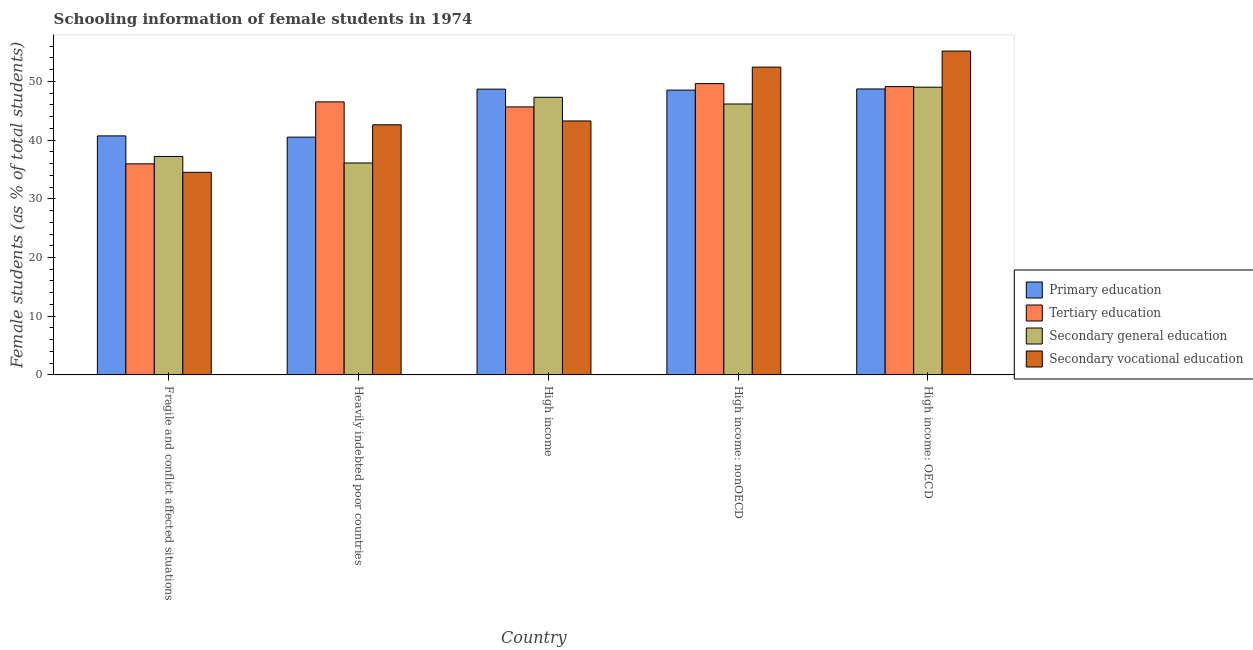How many groups of bars are there?
Give a very brief answer. 5. Are the number of bars per tick equal to the number of legend labels?
Offer a terse response. Yes. Are the number of bars on each tick of the X-axis equal?
Your answer should be compact. Yes. How many bars are there on the 4th tick from the left?
Keep it short and to the point. 4. How many bars are there on the 5th tick from the right?
Offer a terse response. 4. What is the label of the 4th group of bars from the left?
Your answer should be compact. High income: nonOECD. In how many cases, is the number of bars for a given country not equal to the number of legend labels?
Your response must be concise. 0. What is the percentage of female students in tertiary education in High income: nonOECD?
Your answer should be compact. 49.62. Across all countries, what is the maximum percentage of female students in primary education?
Keep it short and to the point. 48.71. Across all countries, what is the minimum percentage of female students in tertiary education?
Offer a very short reply. 35.95. In which country was the percentage of female students in tertiary education maximum?
Provide a short and direct response. High income: nonOECD. In which country was the percentage of female students in tertiary education minimum?
Provide a succinct answer. Fragile and conflict affected situations. What is the total percentage of female students in primary education in the graph?
Offer a very short reply. 227.09. What is the difference between the percentage of female students in tertiary education in Fragile and conflict affected situations and that in High income: nonOECD?
Offer a very short reply. -13.67. What is the difference between the percentage of female students in secondary vocational education in Heavily indebted poor countries and the percentage of female students in secondary education in High income: nonOECD?
Your answer should be compact. -3.54. What is the average percentage of female students in tertiary education per country?
Give a very brief answer. 45.37. What is the difference between the percentage of female students in secondary education and percentage of female students in primary education in Heavily indebted poor countries?
Provide a short and direct response. -4.4. What is the ratio of the percentage of female students in primary education in Heavily indebted poor countries to that in High income: OECD?
Give a very brief answer. 0.83. What is the difference between the highest and the second highest percentage of female students in secondary vocational education?
Make the answer very short. 2.73. What is the difference between the highest and the lowest percentage of female students in secondary education?
Give a very brief answer. 12.91. In how many countries, is the percentage of female students in primary education greater than the average percentage of female students in primary education taken over all countries?
Your response must be concise. 3. Is the sum of the percentage of female students in tertiary education in Heavily indebted poor countries and High income: nonOECD greater than the maximum percentage of female students in secondary education across all countries?
Ensure brevity in your answer.  Yes. Is it the case that in every country, the sum of the percentage of female students in primary education and percentage of female students in secondary education is greater than the sum of percentage of female students in tertiary education and percentage of female students in secondary vocational education?
Keep it short and to the point. No. What does the 3rd bar from the left in High income: nonOECD represents?
Ensure brevity in your answer.  Secondary general education. How many bars are there?
Ensure brevity in your answer.  20. Are all the bars in the graph horizontal?
Your answer should be compact. No. How many countries are there in the graph?
Make the answer very short. 5. Does the graph contain grids?
Your response must be concise. No. How many legend labels are there?
Give a very brief answer. 4. What is the title of the graph?
Your answer should be compact. Schooling information of female students in 1974. What is the label or title of the Y-axis?
Provide a short and direct response. Female students (as % of total students). What is the Female students (as % of total students) in Primary education in Fragile and conflict affected situations?
Offer a very short reply. 40.71. What is the Female students (as % of total students) of Tertiary education in Fragile and conflict affected situations?
Keep it short and to the point. 35.95. What is the Female students (as % of total students) of Secondary general education in Fragile and conflict affected situations?
Give a very brief answer. 37.21. What is the Female students (as % of total students) of Secondary vocational education in Fragile and conflict affected situations?
Offer a terse response. 34.51. What is the Female students (as % of total students) of Primary education in Heavily indebted poor countries?
Offer a terse response. 40.5. What is the Female students (as % of total students) of Tertiary education in Heavily indebted poor countries?
Provide a short and direct response. 46.5. What is the Female students (as % of total students) of Secondary general education in Heavily indebted poor countries?
Offer a terse response. 36.1. What is the Female students (as % of total students) of Secondary vocational education in Heavily indebted poor countries?
Give a very brief answer. 42.6. What is the Female students (as % of total students) in Primary education in High income?
Provide a succinct answer. 48.67. What is the Female students (as % of total students) of Tertiary education in High income?
Provide a succinct answer. 45.65. What is the Female students (as % of total students) in Secondary general education in High income?
Offer a terse response. 47.29. What is the Female students (as % of total students) in Secondary vocational education in High income?
Make the answer very short. 43.25. What is the Female students (as % of total students) in Primary education in High income: nonOECD?
Make the answer very short. 48.51. What is the Female students (as % of total students) of Tertiary education in High income: nonOECD?
Your response must be concise. 49.62. What is the Female students (as % of total students) of Secondary general education in High income: nonOECD?
Make the answer very short. 46.14. What is the Female students (as % of total students) in Secondary vocational education in High income: nonOECD?
Offer a terse response. 52.42. What is the Female students (as % of total students) in Primary education in High income: OECD?
Ensure brevity in your answer.  48.71. What is the Female students (as % of total students) of Tertiary education in High income: OECD?
Your response must be concise. 49.11. What is the Female students (as % of total students) of Secondary general education in High income: OECD?
Your answer should be compact. 49.01. What is the Female students (as % of total students) of Secondary vocational education in High income: OECD?
Give a very brief answer. 55.16. Across all countries, what is the maximum Female students (as % of total students) in Primary education?
Your answer should be very brief. 48.71. Across all countries, what is the maximum Female students (as % of total students) in Tertiary education?
Your answer should be compact. 49.62. Across all countries, what is the maximum Female students (as % of total students) of Secondary general education?
Offer a very short reply. 49.01. Across all countries, what is the maximum Female students (as % of total students) of Secondary vocational education?
Offer a very short reply. 55.16. Across all countries, what is the minimum Female students (as % of total students) of Primary education?
Offer a terse response. 40.5. Across all countries, what is the minimum Female students (as % of total students) of Tertiary education?
Ensure brevity in your answer.  35.95. Across all countries, what is the minimum Female students (as % of total students) in Secondary general education?
Offer a terse response. 36.1. Across all countries, what is the minimum Female students (as % of total students) of Secondary vocational education?
Your answer should be compact. 34.51. What is the total Female students (as % of total students) of Primary education in the graph?
Your answer should be compact. 227.09. What is the total Female students (as % of total students) of Tertiary education in the graph?
Your answer should be compact. 226.83. What is the total Female students (as % of total students) of Secondary general education in the graph?
Offer a very short reply. 215.75. What is the total Female students (as % of total students) of Secondary vocational education in the graph?
Make the answer very short. 227.95. What is the difference between the Female students (as % of total students) in Primary education in Fragile and conflict affected situations and that in Heavily indebted poor countries?
Make the answer very short. 0.21. What is the difference between the Female students (as % of total students) in Tertiary education in Fragile and conflict affected situations and that in Heavily indebted poor countries?
Give a very brief answer. -10.55. What is the difference between the Female students (as % of total students) in Secondary general education in Fragile and conflict affected situations and that in Heavily indebted poor countries?
Your response must be concise. 1.11. What is the difference between the Female students (as % of total students) of Secondary vocational education in Fragile and conflict affected situations and that in Heavily indebted poor countries?
Offer a terse response. -8.09. What is the difference between the Female students (as % of total students) in Primary education in Fragile and conflict affected situations and that in High income?
Provide a short and direct response. -7.96. What is the difference between the Female students (as % of total students) in Tertiary education in Fragile and conflict affected situations and that in High income?
Your answer should be very brief. -9.7. What is the difference between the Female students (as % of total students) in Secondary general education in Fragile and conflict affected situations and that in High income?
Offer a very short reply. -10.08. What is the difference between the Female students (as % of total students) in Secondary vocational education in Fragile and conflict affected situations and that in High income?
Provide a succinct answer. -8.75. What is the difference between the Female students (as % of total students) in Primary education in Fragile and conflict affected situations and that in High income: nonOECD?
Your answer should be very brief. -7.8. What is the difference between the Female students (as % of total students) of Tertiary education in Fragile and conflict affected situations and that in High income: nonOECD?
Your response must be concise. -13.67. What is the difference between the Female students (as % of total students) in Secondary general education in Fragile and conflict affected situations and that in High income: nonOECD?
Give a very brief answer. -8.94. What is the difference between the Female students (as % of total students) of Secondary vocational education in Fragile and conflict affected situations and that in High income: nonOECD?
Offer a terse response. -17.92. What is the difference between the Female students (as % of total students) in Primary education in Fragile and conflict affected situations and that in High income: OECD?
Make the answer very short. -8. What is the difference between the Female students (as % of total students) in Tertiary education in Fragile and conflict affected situations and that in High income: OECD?
Ensure brevity in your answer.  -13.16. What is the difference between the Female students (as % of total students) in Secondary general education in Fragile and conflict affected situations and that in High income: OECD?
Your response must be concise. -11.8. What is the difference between the Female students (as % of total students) in Secondary vocational education in Fragile and conflict affected situations and that in High income: OECD?
Provide a succinct answer. -20.65. What is the difference between the Female students (as % of total students) in Primary education in Heavily indebted poor countries and that in High income?
Your answer should be very brief. -8.17. What is the difference between the Female students (as % of total students) of Tertiary education in Heavily indebted poor countries and that in High income?
Give a very brief answer. 0.85. What is the difference between the Female students (as % of total students) of Secondary general education in Heavily indebted poor countries and that in High income?
Your answer should be very brief. -11.19. What is the difference between the Female students (as % of total students) in Secondary vocational education in Heavily indebted poor countries and that in High income?
Make the answer very short. -0.65. What is the difference between the Female students (as % of total students) of Primary education in Heavily indebted poor countries and that in High income: nonOECD?
Your response must be concise. -8.01. What is the difference between the Female students (as % of total students) of Tertiary education in Heavily indebted poor countries and that in High income: nonOECD?
Give a very brief answer. -3.12. What is the difference between the Female students (as % of total students) in Secondary general education in Heavily indebted poor countries and that in High income: nonOECD?
Make the answer very short. -10.05. What is the difference between the Female students (as % of total students) in Secondary vocational education in Heavily indebted poor countries and that in High income: nonOECD?
Your answer should be very brief. -9.82. What is the difference between the Female students (as % of total students) of Primary education in Heavily indebted poor countries and that in High income: OECD?
Your answer should be compact. -8.21. What is the difference between the Female students (as % of total students) in Tertiary education in Heavily indebted poor countries and that in High income: OECD?
Make the answer very short. -2.61. What is the difference between the Female students (as % of total students) in Secondary general education in Heavily indebted poor countries and that in High income: OECD?
Your answer should be compact. -12.91. What is the difference between the Female students (as % of total students) of Secondary vocational education in Heavily indebted poor countries and that in High income: OECD?
Give a very brief answer. -12.56. What is the difference between the Female students (as % of total students) in Primary education in High income and that in High income: nonOECD?
Ensure brevity in your answer.  0.17. What is the difference between the Female students (as % of total students) of Tertiary education in High income and that in High income: nonOECD?
Provide a succinct answer. -3.97. What is the difference between the Female students (as % of total students) of Secondary general education in High income and that in High income: nonOECD?
Your answer should be compact. 1.14. What is the difference between the Female students (as % of total students) of Secondary vocational education in High income and that in High income: nonOECD?
Provide a short and direct response. -9.17. What is the difference between the Female students (as % of total students) in Primary education in High income and that in High income: OECD?
Provide a short and direct response. -0.03. What is the difference between the Female students (as % of total students) in Tertiary education in High income and that in High income: OECD?
Give a very brief answer. -3.46. What is the difference between the Female students (as % of total students) of Secondary general education in High income and that in High income: OECD?
Ensure brevity in your answer.  -1.72. What is the difference between the Female students (as % of total students) of Secondary vocational education in High income and that in High income: OECD?
Provide a succinct answer. -11.91. What is the difference between the Female students (as % of total students) of Primary education in High income: nonOECD and that in High income: OECD?
Your answer should be very brief. -0.2. What is the difference between the Female students (as % of total students) of Tertiary education in High income: nonOECD and that in High income: OECD?
Make the answer very short. 0.51. What is the difference between the Female students (as % of total students) in Secondary general education in High income: nonOECD and that in High income: OECD?
Give a very brief answer. -2.86. What is the difference between the Female students (as % of total students) of Secondary vocational education in High income: nonOECD and that in High income: OECD?
Offer a terse response. -2.73. What is the difference between the Female students (as % of total students) in Primary education in Fragile and conflict affected situations and the Female students (as % of total students) in Tertiary education in Heavily indebted poor countries?
Your answer should be very brief. -5.79. What is the difference between the Female students (as % of total students) of Primary education in Fragile and conflict affected situations and the Female students (as % of total students) of Secondary general education in Heavily indebted poor countries?
Your response must be concise. 4.61. What is the difference between the Female students (as % of total students) in Primary education in Fragile and conflict affected situations and the Female students (as % of total students) in Secondary vocational education in Heavily indebted poor countries?
Your response must be concise. -1.89. What is the difference between the Female students (as % of total students) of Tertiary education in Fragile and conflict affected situations and the Female students (as % of total students) of Secondary general education in Heavily indebted poor countries?
Your response must be concise. -0.15. What is the difference between the Female students (as % of total students) of Tertiary education in Fragile and conflict affected situations and the Female students (as % of total students) of Secondary vocational education in Heavily indebted poor countries?
Ensure brevity in your answer.  -6.65. What is the difference between the Female students (as % of total students) in Secondary general education in Fragile and conflict affected situations and the Female students (as % of total students) in Secondary vocational education in Heavily indebted poor countries?
Give a very brief answer. -5.39. What is the difference between the Female students (as % of total students) in Primary education in Fragile and conflict affected situations and the Female students (as % of total students) in Tertiary education in High income?
Keep it short and to the point. -4.94. What is the difference between the Female students (as % of total students) of Primary education in Fragile and conflict affected situations and the Female students (as % of total students) of Secondary general education in High income?
Your answer should be compact. -6.58. What is the difference between the Female students (as % of total students) in Primary education in Fragile and conflict affected situations and the Female students (as % of total students) in Secondary vocational education in High income?
Your response must be concise. -2.54. What is the difference between the Female students (as % of total students) in Tertiary education in Fragile and conflict affected situations and the Female students (as % of total students) in Secondary general education in High income?
Provide a succinct answer. -11.34. What is the difference between the Female students (as % of total students) of Tertiary education in Fragile and conflict affected situations and the Female students (as % of total students) of Secondary vocational education in High income?
Ensure brevity in your answer.  -7.3. What is the difference between the Female students (as % of total students) of Secondary general education in Fragile and conflict affected situations and the Female students (as % of total students) of Secondary vocational education in High income?
Ensure brevity in your answer.  -6.05. What is the difference between the Female students (as % of total students) in Primary education in Fragile and conflict affected situations and the Female students (as % of total students) in Tertiary education in High income: nonOECD?
Provide a succinct answer. -8.91. What is the difference between the Female students (as % of total students) in Primary education in Fragile and conflict affected situations and the Female students (as % of total students) in Secondary general education in High income: nonOECD?
Provide a succinct answer. -5.44. What is the difference between the Female students (as % of total students) of Primary education in Fragile and conflict affected situations and the Female students (as % of total students) of Secondary vocational education in High income: nonOECD?
Ensure brevity in your answer.  -11.72. What is the difference between the Female students (as % of total students) in Tertiary education in Fragile and conflict affected situations and the Female students (as % of total students) in Secondary general education in High income: nonOECD?
Keep it short and to the point. -10.19. What is the difference between the Female students (as % of total students) of Tertiary education in Fragile and conflict affected situations and the Female students (as % of total students) of Secondary vocational education in High income: nonOECD?
Your response must be concise. -16.47. What is the difference between the Female students (as % of total students) of Secondary general education in Fragile and conflict affected situations and the Female students (as % of total students) of Secondary vocational education in High income: nonOECD?
Your answer should be very brief. -15.22. What is the difference between the Female students (as % of total students) in Primary education in Fragile and conflict affected situations and the Female students (as % of total students) in Tertiary education in High income: OECD?
Provide a short and direct response. -8.4. What is the difference between the Female students (as % of total students) in Primary education in Fragile and conflict affected situations and the Female students (as % of total students) in Secondary general education in High income: OECD?
Your answer should be very brief. -8.3. What is the difference between the Female students (as % of total students) in Primary education in Fragile and conflict affected situations and the Female students (as % of total students) in Secondary vocational education in High income: OECD?
Provide a succinct answer. -14.45. What is the difference between the Female students (as % of total students) in Tertiary education in Fragile and conflict affected situations and the Female students (as % of total students) in Secondary general education in High income: OECD?
Your answer should be very brief. -13.06. What is the difference between the Female students (as % of total students) of Tertiary education in Fragile and conflict affected situations and the Female students (as % of total students) of Secondary vocational education in High income: OECD?
Ensure brevity in your answer.  -19.21. What is the difference between the Female students (as % of total students) in Secondary general education in Fragile and conflict affected situations and the Female students (as % of total students) in Secondary vocational education in High income: OECD?
Provide a succinct answer. -17.95. What is the difference between the Female students (as % of total students) of Primary education in Heavily indebted poor countries and the Female students (as % of total students) of Tertiary education in High income?
Provide a succinct answer. -5.15. What is the difference between the Female students (as % of total students) of Primary education in Heavily indebted poor countries and the Female students (as % of total students) of Secondary general education in High income?
Offer a very short reply. -6.79. What is the difference between the Female students (as % of total students) of Primary education in Heavily indebted poor countries and the Female students (as % of total students) of Secondary vocational education in High income?
Give a very brief answer. -2.75. What is the difference between the Female students (as % of total students) of Tertiary education in Heavily indebted poor countries and the Female students (as % of total students) of Secondary general education in High income?
Provide a short and direct response. -0.79. What is the difference between the Female students (as % of total students) of Tertiary education in Heavily indebted poor countries and the Female students (as % of total students) of Secondary vocational education in High income?
Your response must be concise. 3.25. What is the difference between the Female students (as % of total students) of Secondary general education in Heavily indebted poor countries and the Female students (as % of total students) of Secondary vocational education in High income?
Provide a succinct answer. -7.16. What is the difference between the Female students (as % of total students) in Primary education in Heavily indebted poor countries and the Female students (as % of total students) in Tertiary education in High income: nonOECD?
Give a very brief answer. -9.12. What is the difference between the Female students (as % of total students) of Primary education in Heavily indebted poor countries and the Female students (as % of total students) of Secondary general education in High income: nonOECD?
Your response must be concise. -5.65. What is the difference between the Female students (as % of total students) in Primary education in Heavily indebted poor countries and the Female students (as % of total students) in Secondary vocational education in High income: nonOECD?
Offer a very short reply. -11.93. What is the difference between the Female students (as % of total students) in Tertiary education in Heavily indebted poor countries and the Female students (as % of total students) in Secondary general education in High income: nonOECD?
Give a very brief answer. 0.36. What is the difference between the Female students (as % of total students) of Tertiary education in Heavily indebted poor countries and the Female students (as % of total students) of Secondary vocational education in High income: nonOECD?
Provide a short and direct response. -5.92. What is the difference between the Female students (as % of total students) in Secondary general education in Heavily indebted poor countries and the Female students (as % of total students) in Secondary vocational education in High income: nonOECD?
Provide a short and direct response. -16.33. What is the difference between the Female students (as % of total students) in Primary education in Heavily indebted poor countries and the Female students (as % of total students) in Tertiary education in High income: OECD?
Your answer should be very brief. -8.61. What is the difference between the Female students (as % of total students) in Primary education in Heavily indebted poor countries and the Female students (as % of total students) in Secondary general education in High income: OECD?
Provide a succinct answer. -8.51. What is the difference between the Female students (as % of total students) of Primary education in Heavily indebted poor countries and the Female students (as % of total students) of Secondary vocational education in High income: OECD?
Keep it short and to the point. -14.66. What is the difference between the Female students (as % of total students) of Tertiary education in Heavily indebted poor countries and the Female students (as % of total students) of Secondary general education in High income: OECD?
Provide a succinct answer. -2.51. What is the difference between the Female students (as % of total students) of Tertiary education in Heavily indebted poor countries and the Female students (as % of total students) of Secondary vocational education in High income: OECD?
Your answer should be compact. -8.66. What is the difference between the Female students (as % of total students) in Secondary general education in Heavily indebted poor countries and the Female students (as % of total students) in Secondary vocational education in High income: OECD?
Make the answer very short. -19.06. What is the difference between the Female students (as % of total students) of Primary education in High income and the Female students (as % of total students) of Tertiary education in High income: nonOECD?
Make the answer very short. -0.94. What is the difference between the Female students (as % of total students) of Primary education in High income and the Female students (as % of total students) of Secondary general education in High income: nonOECD?
Your response must be concise. 2.53. What is the difference between the Female students (as % of total students) of Primary education in High income and the Female students (as % of total students) of Secondary vocational education in High income: nonOECD?
Make the answer very short. -3.75. What is the difference between the Female students (as % of total students) in Tertiary education in High income and the Female students (as % of total students) in Secondary general education in High income: nonOECD?
Your answer should be compact. -0.5. What is the difference between the Female students (as % of total students) of Tertiary education in High income and the Female students (as % of total students) of Secondary vocational education in High income: nonOECD?
Your answer should be very brief. -6.78. What is the difference between the Female students (as % of total students) of Secondary general education in High income and the Female students (as % of total students) of Secondary vocational education in High income: nonOECD?
Keep it short and to the point. -5.14. What is the difference between the Female students (as % of total students) in Primary education in High income and the Female students (as % of total students) in Tertiary education in High income: OECD?
Offer a very short reply. -0.44. What is the difference between the Female students (as % of total students) of Primary education in High income and the Female students (as % of total students) of Secondary general education in High income: OECD?
Your answer should be compact. -0.33. What is the difference between the Female students (as % of total students) of Primary education in High income and the Female students (as % of total students) of Secondary vocational education in High income: OECD?
Keep it short and to the point. -6.49. What is the difference between the Female students (as % of total students) in Tertiary education in High income and the Female students (as % of total students) in Secondary general education in High income: OECD?
Your response must be concise. -3.36. What is the difference between the Female students (as % of total students) in Tertiary education in High income and the Female students (as % of total students) in Secondary vocational education in High income: OECD?
Offer a terse response. -9.51. What is the difference between the Female students (as % of total students) of Secondary general education in High income and the Female students (as % of total students) of Secondary vocational education in High income: OECD?
Provide a succinct answer. -7.87. What is the difference between the Female students (as % of total students) in Primary education in High income: nonOECD and the Female students (as % of total students) in Tertiary education in High income: OECD?
Provide a succinct answer. -0.6. What is the difference between the Female students (as % of total students) of Primary education in High income: nonOECD and the Female students (as % of total students) of Secondary general education in High income: OECD?
Your answer should be compact. -0.5. What is the difference between the Female students (as % of total students) in Primary education in High income: nonOECD and the Female students (as % of total students) in Secondary vocational education in High income: OECD?
Provide a short and direct response. -6.65. What is the difference between the Female students (as % of total students) in Tertiary education in High income: nonOECD and the Female students (as % of total students) in Secondary general education in High income: OECD?
Your answer should be compact. 0.61. What is the difference between the Female students (as % of total students) of Tertiary education in High income: nonOECD and the Female students (as % of total students) of Secondary vocational education in High income: OECD?
Offer a very short reply. -5.54. What is the difference between the Female students (as % of total students) in Secondary general education in High income: nonOECD and the Female students (as % of total students) in Secondary vocational education in High income: OECD?
Your answer should be compact. -9.01. What is the average Female students (as % of total students) in Primary education per country?
Provide a short and direct response. 45.42. What is the average Female students (as % of total students) of Tertiary education per country?
Provide a succinct answer. 45.37. What is the average Female students (as % of total students) of Secondary general education per country?
Provide a short and direct response. 43.15. What is the average Female students (as % of total students) of Secondary vocational education per country?
Give a very brief answer. 45.59. What is the difference between the Female students (as % of total students) of Primary education and Female students (as % of total students) of Tertiary education in Fragile and conflict affected situations?
Your answer should be compact. 4.76. What is the difference between the Female students (as % of total students) of Primary education and Female students (as % of total students) of Secondary general education in Fragile and conflict affected situations?
Make the answer very short. 3.5. What is the difference between the Female students (as % of total students) of Primary education and Female students (as % of total students) of Secondary vocational education in Fragile and conflict affected situations?
Make the answer very short. 6.2. What is the difference between the Female students (as % of total students) of Tertiary education and Female students (as % of total students) of Secondary general education in Fragile and conflict affected situations?
Make the answer very short. -1.26. What is the difference between the Female students (as % of total students) of Tertiary education and Female students (as % of total students) of Secondary vocational education in Fragile and conflict affected situations?
Your answer should be very brief. 1.44. What is the difference between the Female students (as % of total students) of Secondary general education and Female students (as % of total students) of Secondary vocational education in Fragile and conflict affected situations?
Your response must be concise. 2.7. What is the difference between the Female students (as % of total students) in Primary education and Female students (as % of total students) in Tertiary education in Heavily indebted poor countries?
Give a very brief answer. -6. What is the difference between the Female students (as % of total students) of Primary education and Female students (as % of total students) of Secondary general education in Heavily indebted poor countries?
Make the answer very short. 4.4. What is the difference between the Female students (as % of total students) in Primary education and Female students (as % of total students) in Secondary vocational education in Heavily indebted poor countries?
Ensure brevity in your answer.  -2.1. What is the difference between the Female students (as % of total students) of Tertiary education and Female students (as % of total students) of Secondary general education in Heavily indebted poor countries?
Offer a very short reply. 10.4. What is the difference between the Female students (as % of total students) of Tertiary education and Female students (as % of total students) of Secondary vocational education in Heavily indebted poor countries?
Give a very brief answer. 3.9. What is the difference between the Female students (as % of total students) of Secondary general education and Female students (as % of total students) of Secondary vocational education in Heavily indebted poor countries?
Provide a short and direct response. -6.5. What is the difference between the Female students (as % of total students) in Primary education and Female students (as % of total students) in Tertiary education in High income?
Ensure brevity in your answer.  3.02. What is the difference between the Female students (as % of total students) in Primary education and Female students (as % of total students) in Secondary general education in High income?
Offer a very short reply. 1.39. What is the difference between the Female students (as % of total students) in Primary education and Female students (as % of total students) in Secondary vocational education in High income?
Give a very brief answer. 5.42. What is the difference between the Female students (as % of total students) in Tertiary education and Female students (as % of total students) in Secondary general education in High income?
Provide a short and direct response. -1.64. What is the difference between the Female students (as % of total students) of Tertiary education and Female students (as % of total students) of Secondary vocational education in High income?
Ensure brevity in your answer.  2.4. What is the difference between the Female students (as % of total students) of Secondary general education and Female students (as % of total students) of Secondary vocational education in High income?
Give a very brief answer. 4.03. What is the difference between the Female students (as % of total students) of Primary education and Female students (as % of total students) of Tertiary education in High income: nonOECD?
Ensure brevity in your answer.  -1.11. What is the difference between the Female students (as % of total students) of Primary education and Female students (as % of total students) of Secondary general education in High income: nonOECD?
Make the answer very short. 2.36. What is the difference between the Female students (as % of total students) of Primary education and Female students (as % of total students) of Secondary vocational education in High income: nonOECD?
Your answer should be very brief. -3.92. What is the difference between the Female students (as % of total students) in Tertiary education and Female students (as % of total students) in Secondary general education in High income: nonOECD?
Your answer should be very brief. 3.47. What is the difference between the Female students (as % of total students) in Tertiary education and Female students (as % of total students) in Secondary vocational education in High income: nonOECD?
Your answer should be very brief. -2.81. What is the difference between the Female students (as % of total students) in Secondary general education and Female students (as % of total students) in Secondary vocational education in High income: nonOECD?
Your answer should be very brief. -6.28. What is the difference between the Female students (as % of total students) in Primary education and Female students (as % of total students) in Tertiary education in High income: OECD?
Offer a very short reply. -0.41. What is the difference between the Female students (as % of total students) of Primary education and Female students (as % of total students) of Secondary general education in High income: OECD?
Your answer should be compact. -0.3. What is the difference between the Female students (as % of total students) in Primary education and Female students (as % of total students) in Secondary vocational education in High income: OECD?
Offer a terse response. -6.45. What is the difference between the Female students (as % of total students) of Tertiary education and Female students (as % of total students) of Secondary general education in High income: OECD?
Make the answer very short. 0.1. What is the difference between the Female students (as % of total students) of Tertiary education and Female students (as % of total students) of Secondary vocational education in High income: OECD?
Your answer should be very brief. -6.05. What is the difference between the Female students (as % of total students) of Secondary general education and Female students (as % of total students) of Secondary vocational education in High income: OECD?
Provide a short and direct response. -6.15. What is the ratio of the Female students (as % of total students) of Primary education in Fragile and conflict affected situations to that in Heavily indebted poor countries?
Give a very brief answer. 1.01. What is the ratio of the Female students (as % of total students) in Tertiary education in Fragile and conflict affected situations to that in Heavily indebted poor countries?
Your answer should be very brief. 0.77. What is the ratio of the Female students (as % of total students) of Secondary general education in Fragile and conflict affected situations to that in Heavily indebted poor countries?
Offer a terse response. 1.03. What is the ratio of the Female students (as % of total students) of Secondary vocational education in Fragile and conflict affected situations to that in Heavily indebted poor countries?
Your response must be concise. 0.81. What is the ratio of the Female students (as % of total students) of Primary education in Fragile and conflict affected situations to that in High income?
Offer a very short reply. 0.84. What is the ratio of the Female students (as % of total students) of Tertiary education in Fragile and conflict affected situations to that in High income?
Keep it short and to the point. 0.79. What is the ratio of the Female students (as % of total students) of Secondary general education in Fragile and conflict affected situations to that in High income?
Keep it short and to the point. 0.79. What is the ratio of the Female students (as % of total students) in Secondary vocational education in Fragile and conflict affected situations to that in High income?
Make the answer very short. 0.8. What is the ratio of the Female students (as % of total students) of Primary education in Fragile and conflict affected situations to that in High income: nonOECD?
Provide a short and direct response. 0.84. What is the ratio of the Female students (as % of total students) in Tertiary education in Fragile and conflict affected situations to that in High income: nonOECD?
Your answer should be very brief. 0.72. What is the ratio of the Female students (as % of total students) of Secondary general education in Fragile and conflict affected situations to that in High income: nonOECD?
Provide a succinct answer. 0.81. What is the ratio of the Female students (as % of total students) of Secondary vocational education in Fragile and conflict affected situations to that in High income: nonOECD?
Provide a succinct answer. 0.66. What is the ratio of the Female students (as % of total students) of Primary education in Fragile and conflict affected situations to that in High income: OECD?
Give a very brief answer. 0.84. What is the ratio of the Female students (as % of total students) of Tertiary education in Fragile and conflict affected situations to that in High income: OECD?
Provide a succinct answer. 0.73. What is the ratio of the Female students (as % of total students) in Secondary general education in Fragile and conflict affected situations to that in High income: OECD?
Provide a short and direct response. 0.76. What is the ratio of the Female students (as % of total students) in Secondary vocational education in Fragile and conflict affected situations to that in High income: OECD?
Your response must be concise. 0.63. What is the ratio of the Female students (as % of total students) of Primary education in Heavily indebted poor countries to that in High income?
Offer a very short reply. 0.83. What is the ratio of the Female students (as % of total students) of Tertiary education in Heavily indebted poor countries to that in High income?
Ensure brevity in your answer.  1.02. What is the ratio of the Female students (as % of total students) in Secondary general education in Heavily indebted poor countries to that in High income?
Provide a succinct answer. 0.76. What is the ratio of the Female students (as % of total students) in Secondary vocational education in Heavily indebted poor countries to that in High income?
Make the answer very short. 0.98. What is the ratio of the Female students (as % of total students) of Primary education in Heavily indebted poor countries to that in High income: nonOECD?
Ensure brevity in your answer.  0.83. What is the ratio of the Female students (as % of total students) in Tertiary education in Heavily indebted poor countries to that in High income: nonOECD?
Provide a succinct answer. 0.94. What is the ratio of the Female students (as % of total students) in Secondary general education in Heavily indebted poor countries to that in High income: nonOECD?
Offer a terse response. 0.78. What is the ratio of the Female students (as % of total students) of Secondary vocational education in Heavily indebted poor countries to that in High income: nonOECD?
Keep it short and to the point. 0.81. What is the ratio of the Female students (as % of total students) of Primary education in Heavily indebted poor countries to that in High income: OECD?
Ensure brevity in your answer.  0.83. What is the ratio of the Female students (as % of total students) of Tertiary education in Heavily indebted poor countries to that in High income: OECD?
Make the answer very short. 0.95. What is the ratio of the Female students (as % of total students) of Secondary general education in Heavily indebted poor countries to that in High income: OECD?
Make the answer very short. 0.74. What is the ratio of the Female students (as % of total students) of Secondary vocational education in Heavily indebted poor countries to that in High income: OECD?
Provide a succinct answer. 0.77. What is the ratio of the Female students (as % of total students) in Primary education in High income to that in High income: nonOECD?
Ensure brevity in your answer.  1. What is the ratio of the Female students (as % of total students) in Secondary general education in High income to that in High income: nonOECD?
Provide a succinct answer. 1.02. What is the ratio of the Female students (as % of total students) in Secondary vocational education in High income to that in High income: nonOECD?
Provide a short and direct response. 0.83. What is the ratio of the Female students (as % of total students) of Tertiary education in High income to that in High income: OECD?
Your answer should be compact. 0.93. What is the ratio of the Female students (as % of total students) of Secondary general education in High income to that in High income: OECD?
Ensure brevity in your answer.  0.96. What is the ratio of the Female students (as % of total students) of Secondary vocational education in High income to that in High income: OECD?
Give a very brief answer. 0.78. What is the ratio of the Female students (as % of total students) of Tertiary education in High income: nonOECD to that in High income: OECD?
Keep it short and to the point. 1.01. What is the ratio of the Female students (as % of total students) of Secondary general education in High income: nonOECD to that in High income: OECD?
Your response must be concise. 0.94. What is the ratio of the Female students (as % of total students) in Secondary vocational education in High income: nonOECD to that in High income: OECD?
Offer a terse response. 0.95. What is the difference between the highest and the second highest Female students (as % of total students) of Primary education?
Provide a short and direct response. 0.03. What is the difference between the highest and the second highest Female students (as % of total students) of Tertiary education?
Offer a very short reply. 0.51. What is the difference between the highest and the second highest Female students (as % of total students) of Secondary general education?
Your answer should be very brief. 1.72. What is the difference between the highest and the second highest Female students (as % of total students) of Secondary vocational education?
Provide a succinct answer. 2.73. What is the difference between the highest and the lowest Female students (as % of total students) in Primary education?
Provide a short and direct response. 8.21. What is the difference between the highest and the lowest Female students (as % of total students) of Tertiary education?
Your answer should be very brief. 13.67. What is the difference between the highest and the lowest Female students (as % of total students) in Secondary general education?
Offer a very short reply. 12.91. What is the difference between the highest and the lowest Female students (as % of total students) in Secondary vocational education?
Provide a succinct answer. 20.65. 